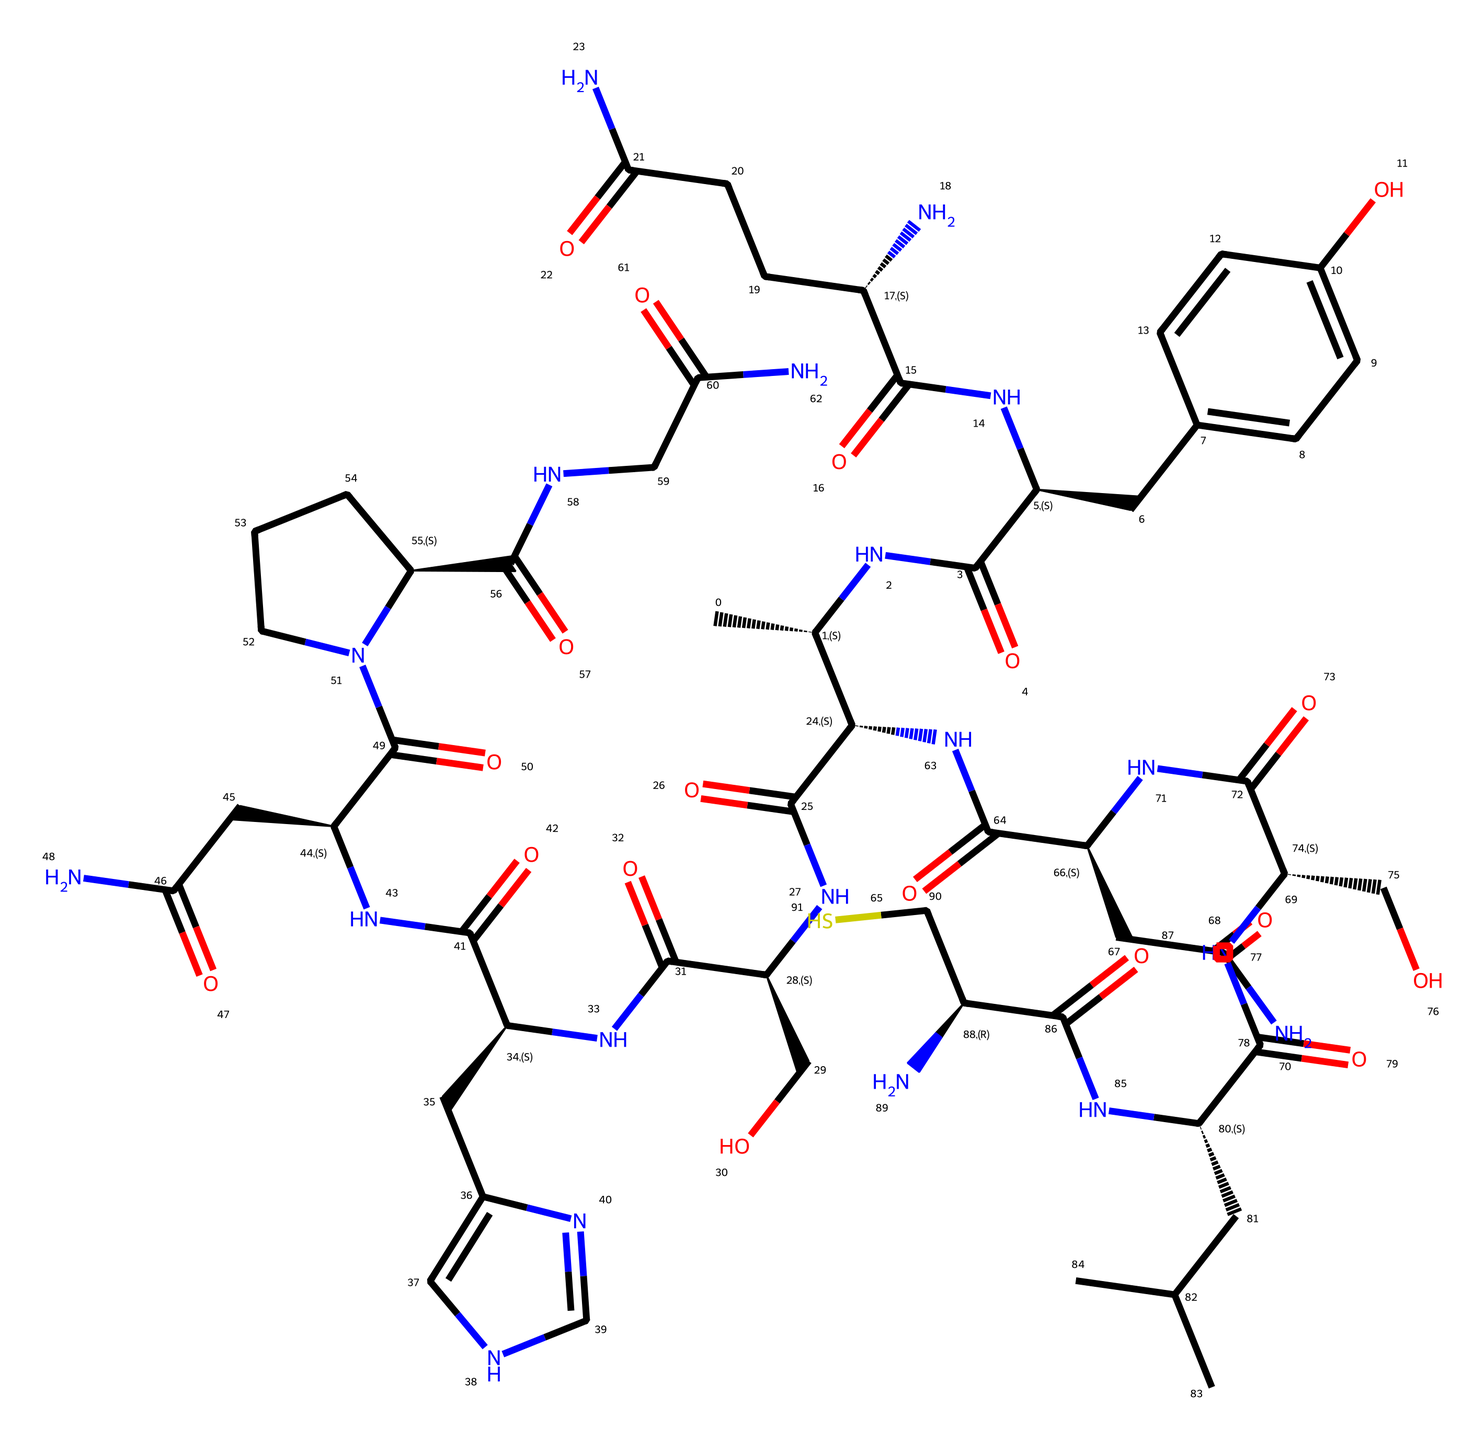What is the molecular formula of oxytocin represented in the SMILES? The SMILES notation contains various atoms such as carbon (C), nitrogen (N), and oxygen (O). Counting these gives us the molecular formula: C43H66N12O12S2.
Answer: C43H66N12O12S2 How many nitrogen atoms are present in oxytocin? By examining the SMILES representation, there are twelve occurrences of 'N', indicating that there are twelve nitrogen atoms in the molecule.
Answer: 12 What is the primary functional group of oxytocin? The presence of amide and hydroxyl groups can be identified in the structure; specifically, the amide group (–C(=O)N–) is prominent due to its multiple occurrences, indicating that it is the primary functional group here.
Answer: amide Does oxytocin contain any rings in its structure? Analyzing the SMILES shows that there are cyclic structures present, indicated by various atoms bonded in a closed manner, which confirms that oxytocin has rings in its structure.
Answer: yes What type of hormonal classification does oxytocin belong to? Given its role in bonding, social behavior, and reproductive functions, oxytocin can be classified as a peptide hormone, as it consists of a chain of amino acids.
Answer: peptide hormone What would be the consequence of a mutation affecting the nitrogen atoms in oxytocin? Since nitrogen atoms are inherent to the amide functional groups, a mutation could disrupt the peptide formation and alter its biological function, such as bonding behavior, due to interference with peptide bonds.
Answer: altered bonding function 